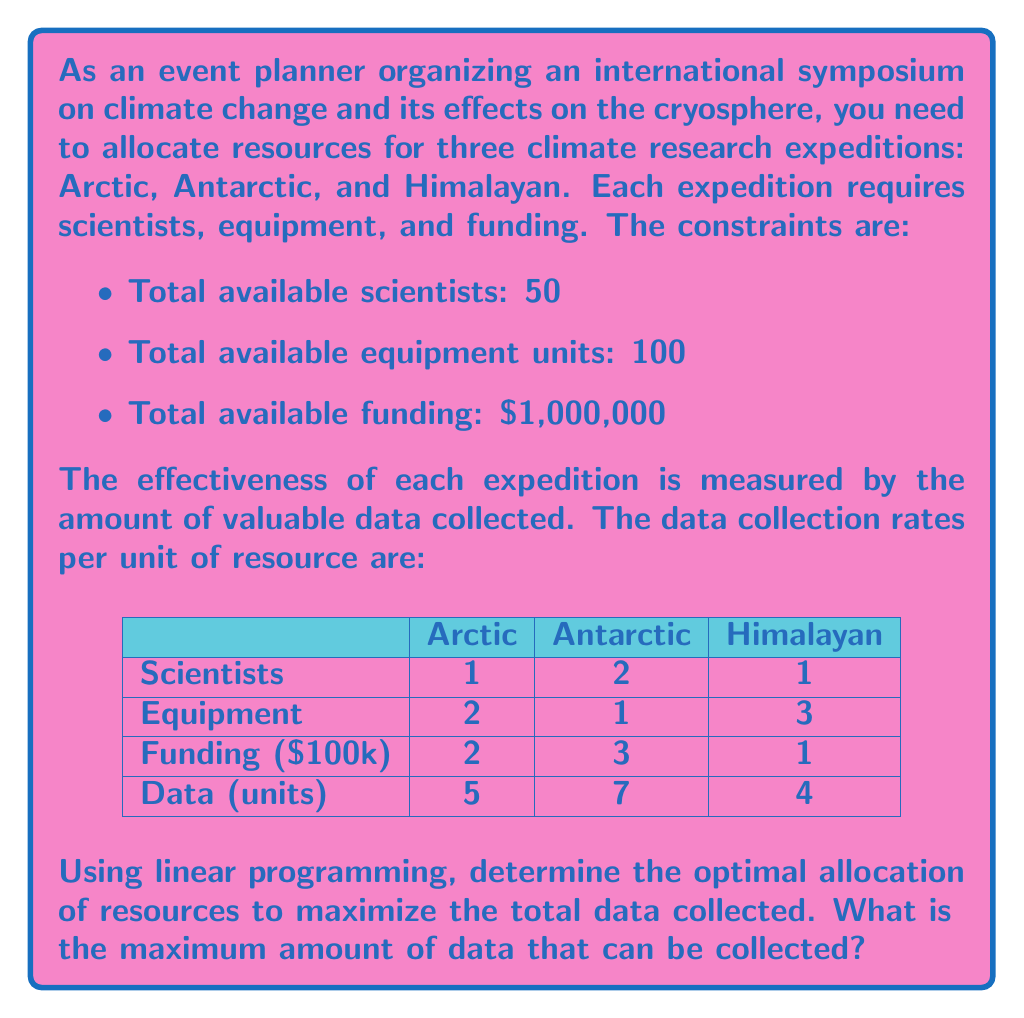What is the answer to this math problem? Let's solve this problem using the simplex method of linear programming:

1) Define variables:
   Let $x_1$, $x_2$, and $x_3$ be the number of units allocated to Arctic, Antarctic, and Himalayan expeditions respectively.

2) Objective function:
   Maximize $Z = 5x_1 + 7x_2 + 4x_3$

3) Constraints:
   Scientists: $x_1 + 2x_2 + x_3 \leq 50$
   Equipment: $2x_1 + x_2 + 3x_3 \leq 100$
   Funding: $2x_1 + 3x_2 + x_3 \leq 10$ (in $100,000 units)
   Non-negativity: $x_1, x_2, x_3 \geq 0$

4) Convert to standard form by adding slack variables $s_1$, $s_2$, $s_3$:
   $x_1 + 2x_2 + x_3 + s_1 = 50$
   $2x_1 + x_2 + 3x_3 + s_2 = 100$
   $2x_1 + 3x_2 + x_3 + s_3 = 10$

5) Initial tableau:
   $$\begin{array}{c|cccccc|c}
     & x_1 & x_2 & x_3 & s_1 & s_2 & s_3 & RHS \\
   \hline
   s_1 & 1 & 2 & 1 & 1 & 0 & 0 & 50 \\
   s_2 & 2 & 1 & 3 & 0 & 1 & 0 & 100 \\
   s_3 & 2 & 3 & 1 & 0 & 0 & 1 & 10 \\
   \hline
   Z & -5 & -7 & -4 & 0 & 0 & 0 & 0
   \end{array}$$

6) Perform pivot operations until all entries in the Z-row are non-negative.

7) Final optimal tableau:
   $$\begin{array}{c|cccccc|c}
     & x_1 & x_2 & x_3 & s_1 & s_2 & s_3 & RHS \\
   \hline
   x_2 & 0 & 1 & 0 & \frac{1}{3} & 0 & -\frac{1}{3} & \frac{10}{3} \\
   x_3 & 0 & 0 & 1 & -\frac{1}{3} & \frac{1}{3} & -\frac{1}{3} & \frac{20}{3} \\
   x_1 & 1 & 0 & 0 & -\frac{1}{3} & 0 & \frac{2}{3} & \frac{10}{3} \\
   \hline
   Z & 0 & 0 & 0 & \frac{1}{3} & \frac{4}{3} & \frac{5}{3} & \frac{230}{3}
   \end{array}$$

8) The optimal solution is:
   $x_1 = \frac{10}{3}$, $x_2 = \frac{10}{3}$, $x_3 = \frac{20}{3}$

9) The maximum value of the objective function is:
   $Z_{max} = \frac{230}{3} \approx 76.67$ units of data
Answer: $\frac{230}{3}$ units of data 